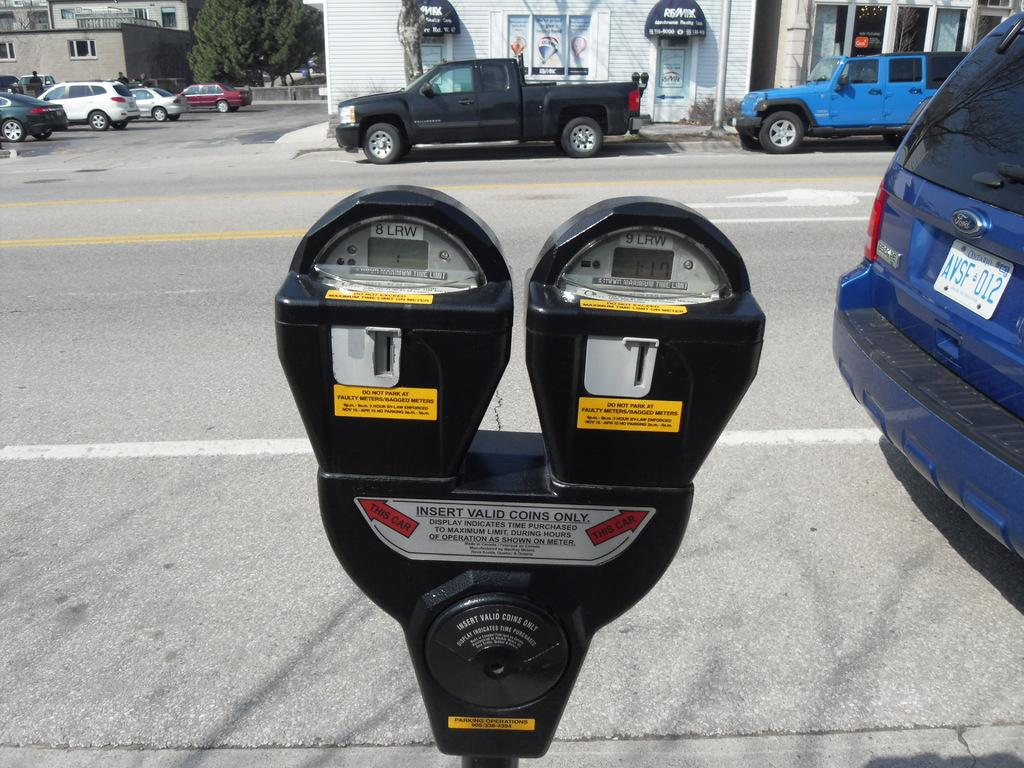<image>
Summarize the visual content of the image. A blue car sits in front of a parking meter which is set to expire in an hour and seventeen minutes. 